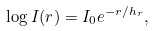Convert formula to latex. <formula><loc_0><loc_0><loc_500><loc_500>\log I ( r ) = I _ { 0 } e ^ { - r / h _ { r } } ,</formula> 